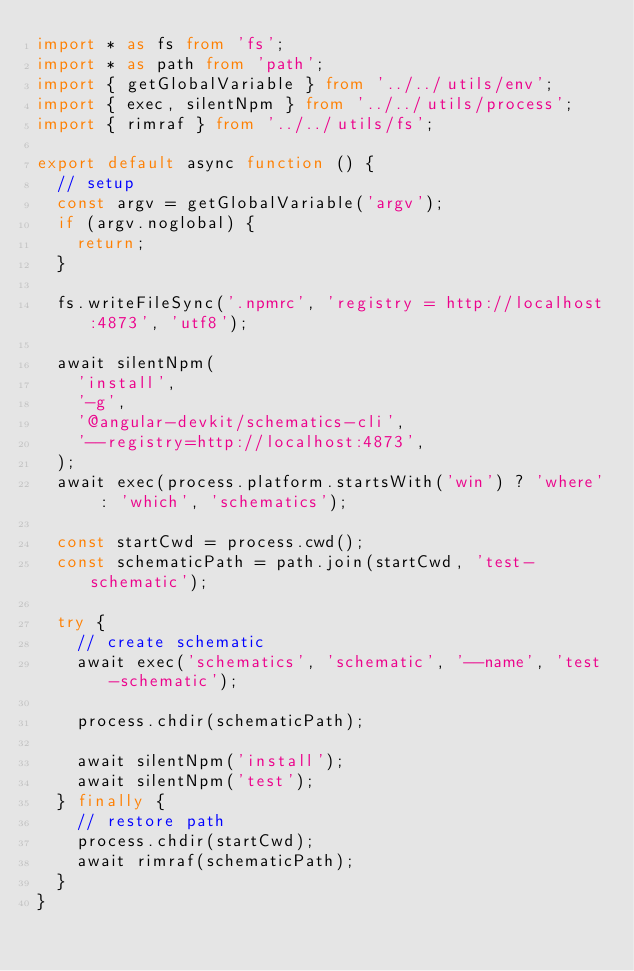<code> <loc_0><loc_0><loc_500><loc_500><_TypeScript_>import * as fs from 'fs';
import * as path from 'path';
import { getGlobalVariable } from '../../utils/env';
import { exec, silentNpm } from '../../utils/process';
import { rimraf } from '../../utils/fs';

export default async function () {
  // setup
  const argv = getGlobalVariable('argv');
  if (argv.noglobal) {
    return;
  }

  fs.writeFileSync('.npmrc', 'registry = http://localhost:4873', 'utf8');

  await silentNpm(
    'install',
    '-g',
    '@angular-devkit/schematics-cli',
    '--registry=http://localhost:4873',
  );
  await exec(process.platform.startsWith('win') ? 'where' : 'which', 'schematics');

  const startCwd = process.cwd();
  const schematicPath = path.join(startCwd, 'test-schematic');

  try {
    // create schematic
    await exec('schematics', 'schematic', '--name', 'test-schematic');

    process.chdir(schematicPath);

    await silentNpm('install');
    await silentNpm('test');
  } finally {
    // restore path
    process.chdir(startCwd);
    await rimraf(schematicPath);
  }
}
</code> 